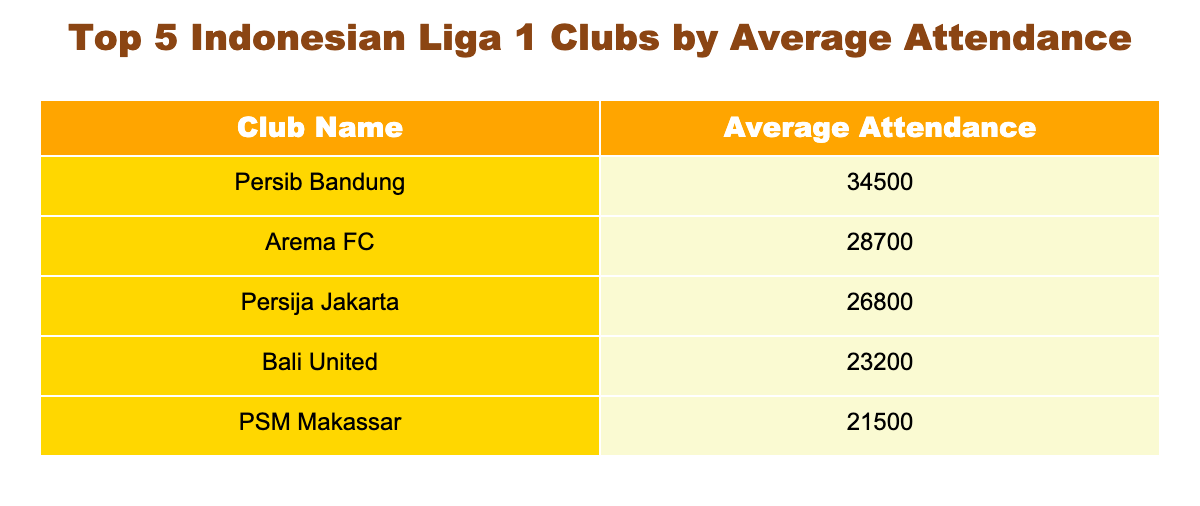What is the average attendance for Persib Bandung? The table directly shows that Persib Bandung has an average attendance of 34,500.
Answer: 34,500 Which club has the lowest average attendance? By looking at the attendance figures listed, PSM Makassar has the lowest average attendance at 21,500.
Answer: 21,500 What is the difference in average attendance between Arema FC and Bali United? Arema FC has an average attendance of 28,700 and Bali United has 23,200. The difference is calculated by subtracting Bali United's attendance from Arema FC's: 28,700 - 23,200 = 5,500.
Answer: 5,500 Is it true that Persija Jakarta has a higher average attendance than PSM Makassar? Checking the average attendances, Persija Jakarta has 26,800 while PSM Makassar has 21,500. Since 26,800 is greater than 21,500, the statement is true.
Answer: Yes What would be the average attendance of the top three clubs (Persib Bandung, Arema FC, and Persija Jakarta)? To find the average, we add the attendances of the top three clubs: 34,500 (Persib) + 28,700 (Arema) + 26,800 (Persija) = 90,000. There are three clubs, so we divide by 3: 90,000 / 3 = 30,000.
Answer: 30,000 What is the total average attendance of all five clubs combined? The total average attendance can be calculated by adding all attendances together: 34,500 (Persib) + 28,700 (Arema) + 26,800 (Persija) + 23,200 (Bali) + 21,500 (PSM) = 134,700.
Answer: 134,700 Which clubs have an average attendance greater than 25,000? Referring to the table, the clubs with attendance above 25,000 are Persib Bandung (34,500) and Arema FC (28,700), while Persija Jakarta is just below at 26,800. Therefore, only Persib and Arema exceed 25,000.
Answer: Persib Bandung, Arema FC What is the average attendance of the bottom two clubs (Bali United and PSM Makassar)? The average attendance for Bali United is 23,200, and for PSM Makassar, it is 21,500. The average is calculated by adding these two values (23,200 + 21,500 = 44,700) and dividing by 2: 44,700 / 2 = 22,350.
Answer: 22,350 Is Bali United's average attendance higher than Persija Jakarta's? Bali United has an average attendance of 23,200 and Persija Jakarta has 26,800. Since 23,200 is less than 26,800, the statement is false.
Answer: No 